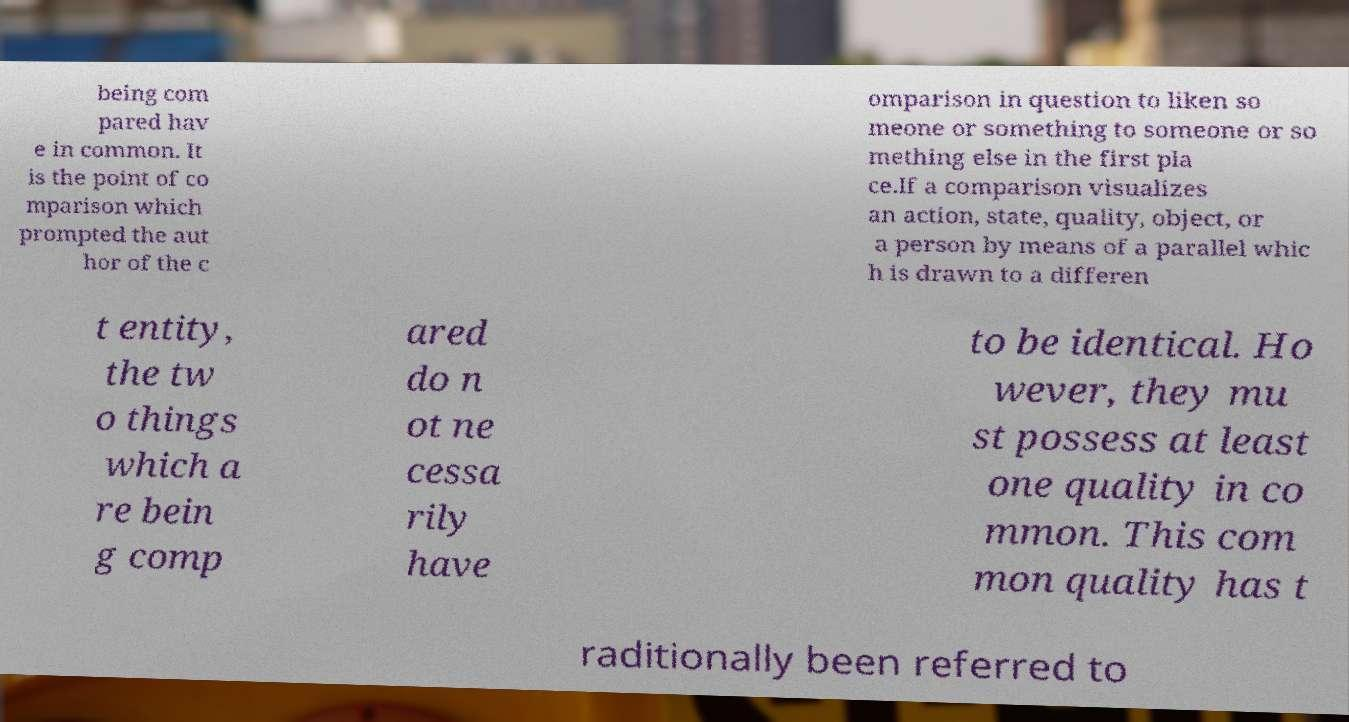Can you read and provide the text displayed in the image?This photo seems to have some interesting text. Can you extract and type it out for me? being com pared hav e in common. It is the point of co mparison which prompted the aut hor of the c omparison in question to liken so meone or something to someone or so mething else in the first pla ce.If a comparison visualizes an action, state, quality, object, or a person by means of a parallel whic h is drawn to a differen t entity, the tw o things which a re bein g comp ared do n ot ne cessa rily have to be identical. Ho wever, they mu st possess at least one quality in co mmon. This com mon quality has t raditionally been referred to 